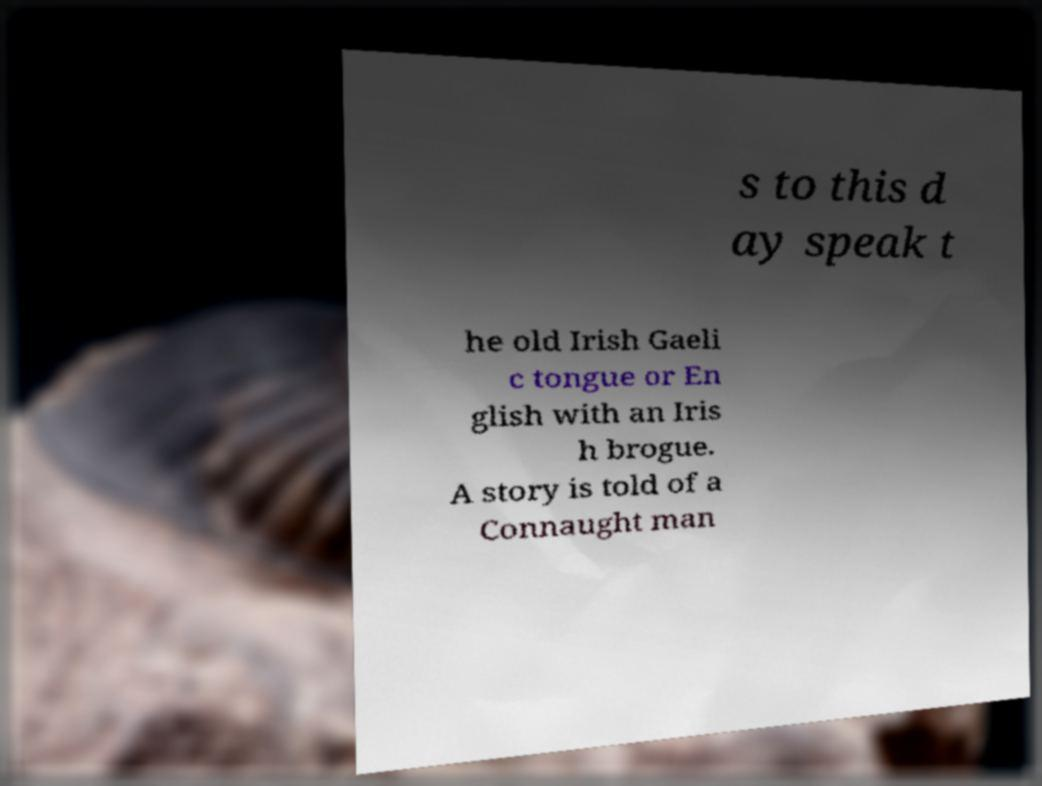I need the written content from this picture converted into text. Can you do that? s to this d ay speak t he old Irish Gaeli c tongue or En glish with an Iris h brogue. A story is told of a Connaught man 